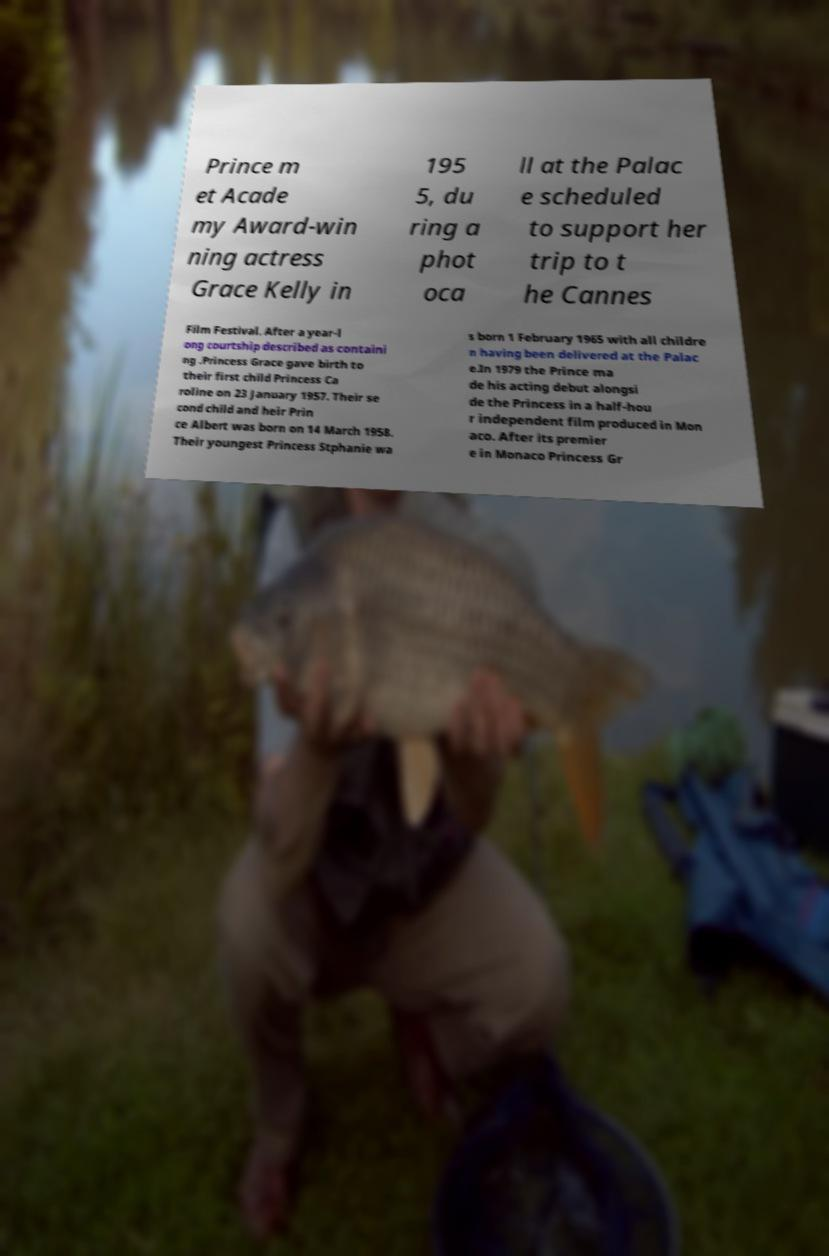Could you extract and type out the text from this image? Prince m et Acade my Award-win ning actress Grace Kelly in 195 5, du ring a phot oca ll at the Palac e scheduled to support her trip to t he Cannes Film Festival. After a year-l ong courtship described as containi ng .Princess Grace gave birth to their first child Princess Ca roline on 23 January 1957. Their se cond child and heir Prin ce Albert was born on 14 March 1958. Their youngest Princess Stphanie wa s born 1 February 1965 with all childre n having been delivered at the Palac e.In 1979 the Prince ma de his acting debut alongsi de the Princess in a half-hou r independent film produced in Mon aco. After its premier e in Monaco Princess Gr 